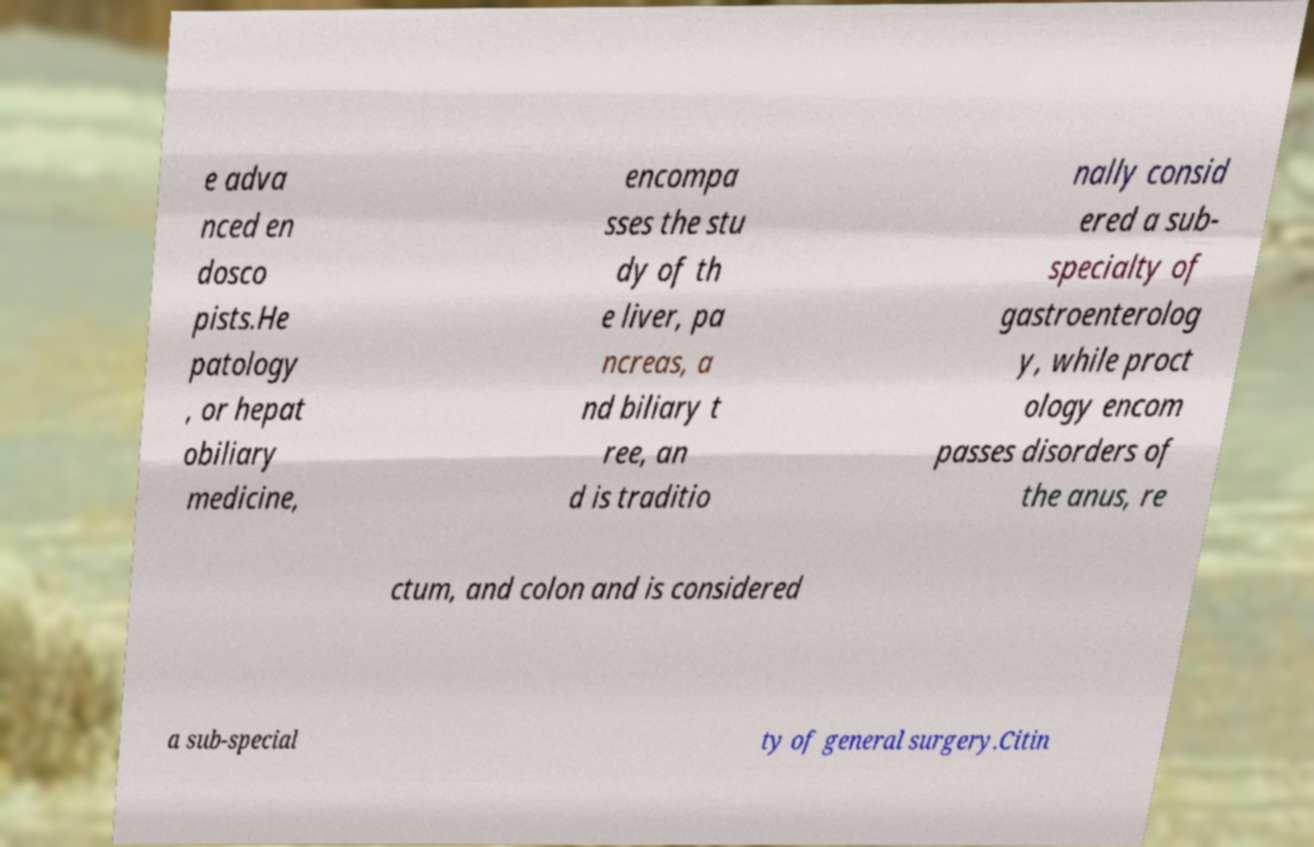Please identify and transcribe the text found in this image. e adva nced en dosco pists.He patology , or hepat obiliary medicine, encompa sses the stu dy of th e liver, pa ncreas, a nd biliary t ree, an d is traditio nally consid ered a sub- specialty of gastroenterolog y, while proct ology encom passes disorders of the anus, re ctum, and colon and is considered a sub-special ty of general surgery.Citin 